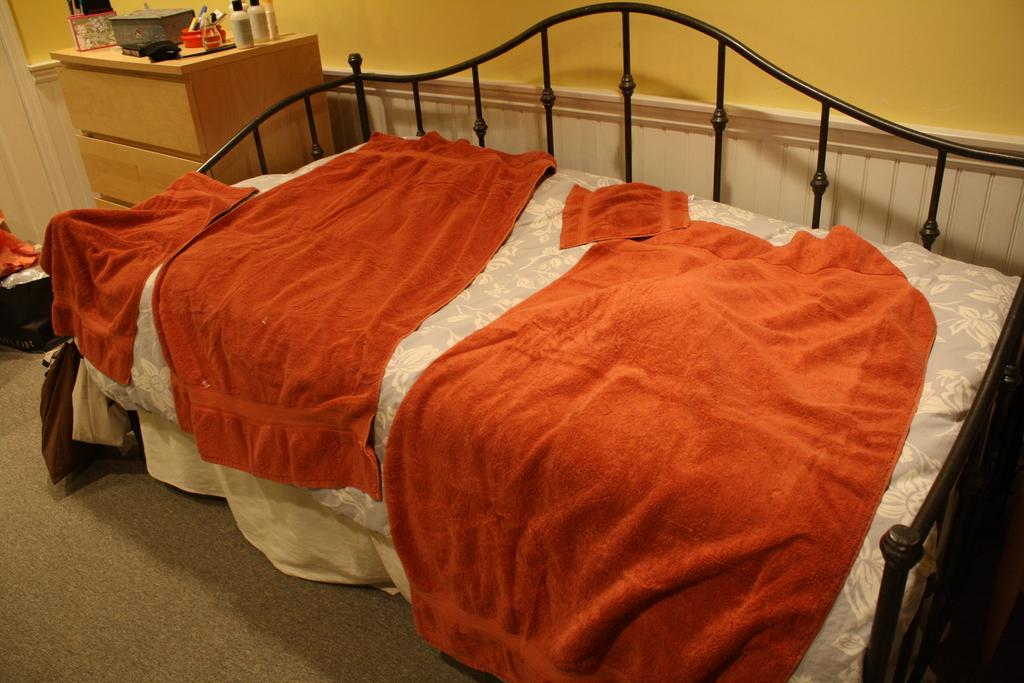What is on the bed in the image? There are clothes on the bed. What is on the table in the image? There are bottles and other objects on the table. Can you describe the color of the wall in the image? The wall is yellow in color. How many objects can be seen on the table in the image? There are at least two objects on the table, the bottles and other unspecified objects. How much sugar is in the bottles on the table? There is no information about the contents of the bottles in the image, so we cannot determine if there is sugar in them. What type of art is hanging on the wall in the image? There is no art visible on the wall in the image; it is simply yellow in color. 